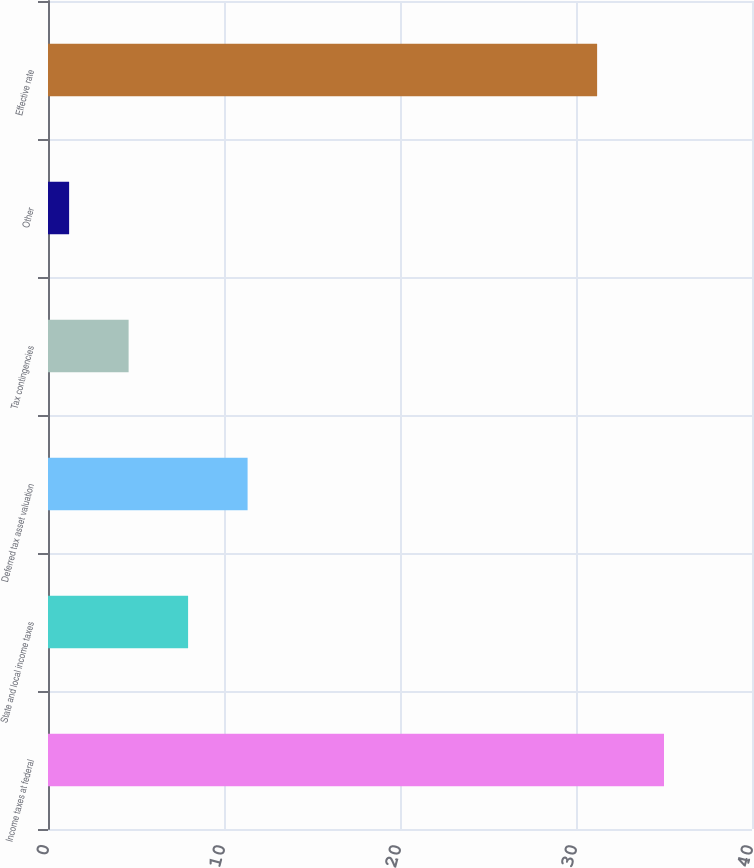<chart> <loc_0><loc_0><loc_500><loc_500><bar_chart><fcel>Income taxes at federal<fcel>State and local income taxes<fcel>Deferred tax asset valuation<fcel>Tax contingencies<fcel>Other<fcel>Effective rate<nl><fcel>35<fcel>7.96<fcel>11.34<fcel>4.58<fcel>1.2<fcel>31.2<nl></chart> 